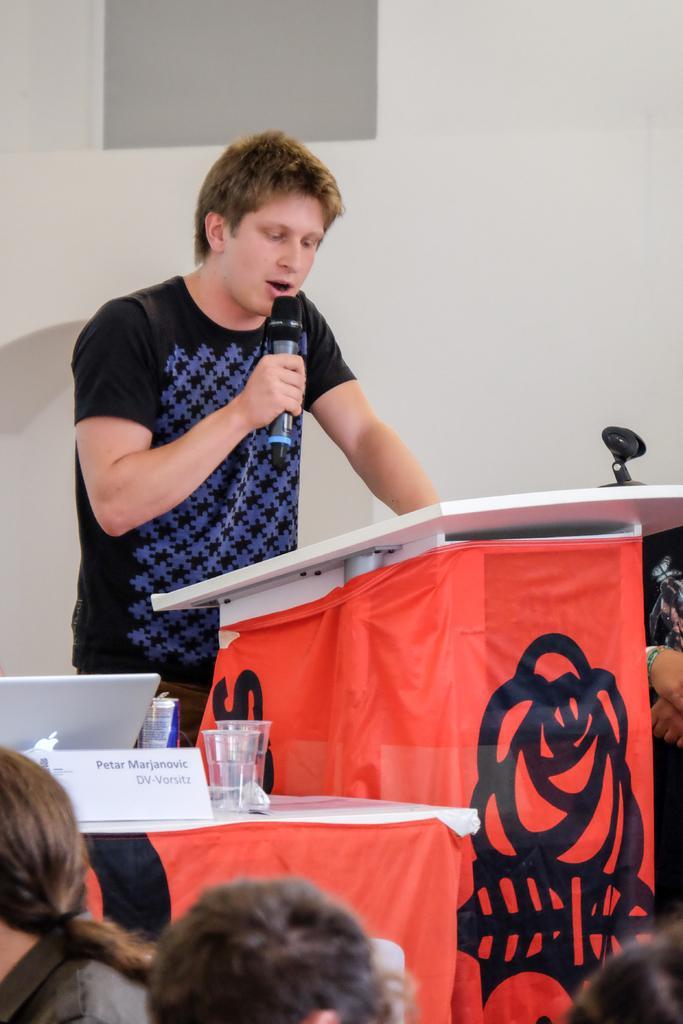Can you describe this image briefly? In this picture we can observe a person wearing black color t-shirt holding a mic in his hand. He is standing in front of white color podium. There is a red color cloth. We can observe some people sitting. There is a table on which we can observe name board and a glass. 